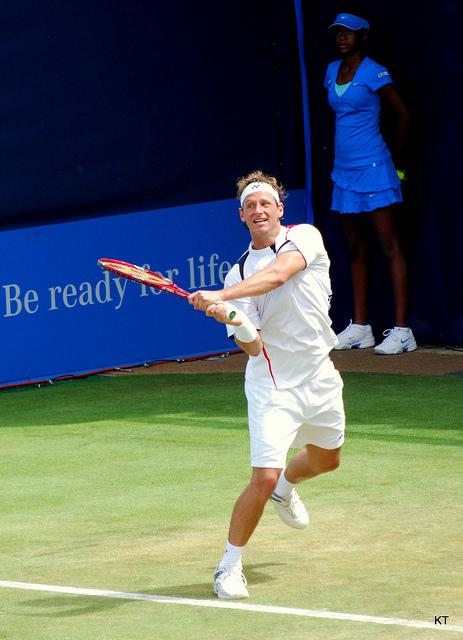What color is his headband?
Concise answer only. White. Is the girl in motion?
Quick response, please. No. Is the man happy?
Answer briefly. Yes. What is this man wearing on his head?
Be succinct. Sweatband. Which sport is this?
Write a very short answer. Tennis. What language is on the side?
Quick response, please. English. Is he about to swing to his left or his right?
Give a very brief answer. Left. 